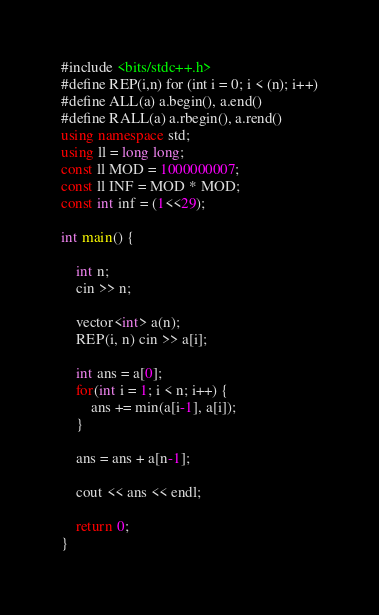Convert code to text. <code><loc_0><loc_0><loc_500><loc_500><_C++_>#include <bits/stdc++.h>
#define REP(i,n) for (int i = 0; i < (n); i++)
#define ALL(a) a.begin(), a.end()
#define RALL(a) a.rbegin(), a.rend()
using namespace std;
using ll = long long;
const ll MOD = 1000000007;
const ll INF = MOD * MOD;
const int inf = (1<<29);

int main() {

    int n;
    cin >> n;

    vector<int> a(n);
    REP(i, n) cin >> a[i];
    
    int ans = a[0];    
    for(int i = 1; i < n; i++) {
        ans += min(a[i-1], a[i]);
    }

    ans = ans + a[n-1];

    cout << ans << endl;
    
    return 0;
}</code> 